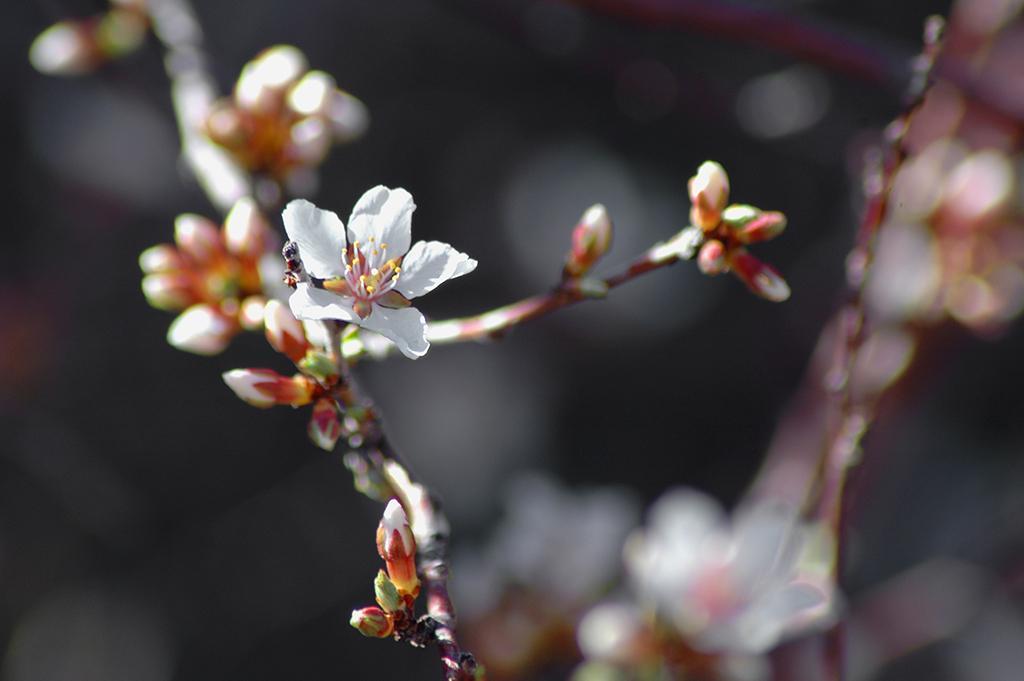Could you give a brief overview of what you see in this image? In this picture we can see flowers and in the background it is blurry. 